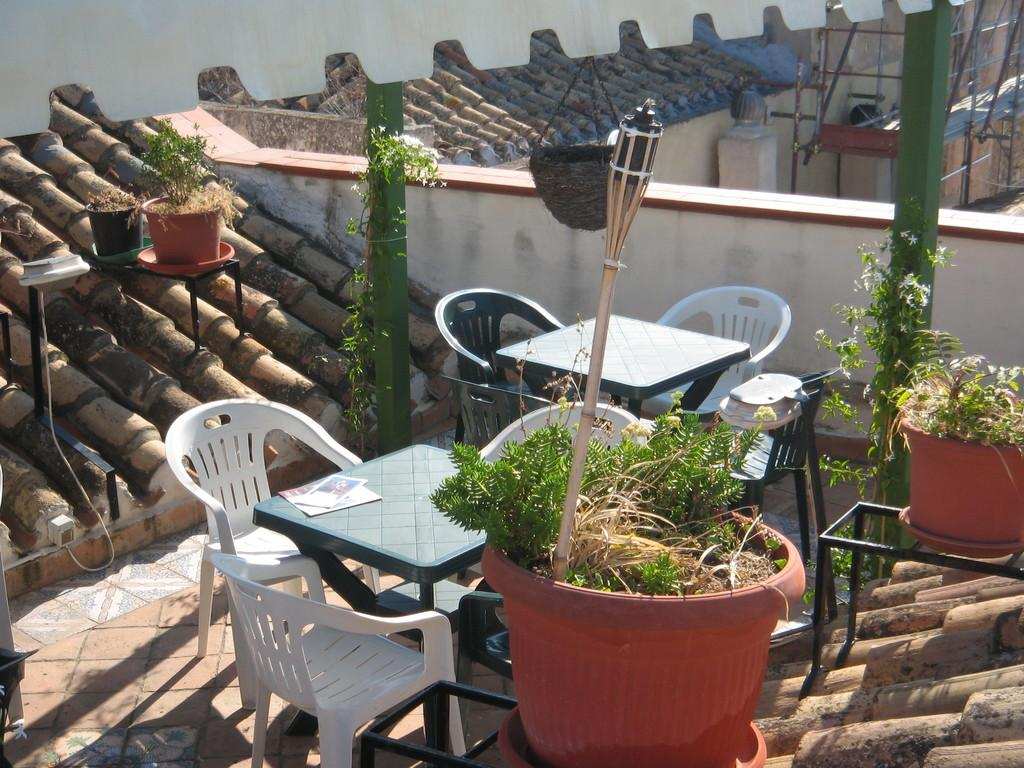What is the main subject of the image? The main subject of the image is the roof of a building. What furniture can be seen on the roof? There is a chair and tables on the roof. What type of object is present on the roof for planting? There is a pot on the roof for planting. What else can be found on the roof besides furniture and planting objects? There are poles and a wall on the roof. Can you describe the pipe visible in the top right corner of the image? In the top right corner of the image, there is a pipe near the wall. How many insects can be seen crawling on the beds in the image? There are no beds or insects present in the image; it shows the roof of a building with various objects and structures. 